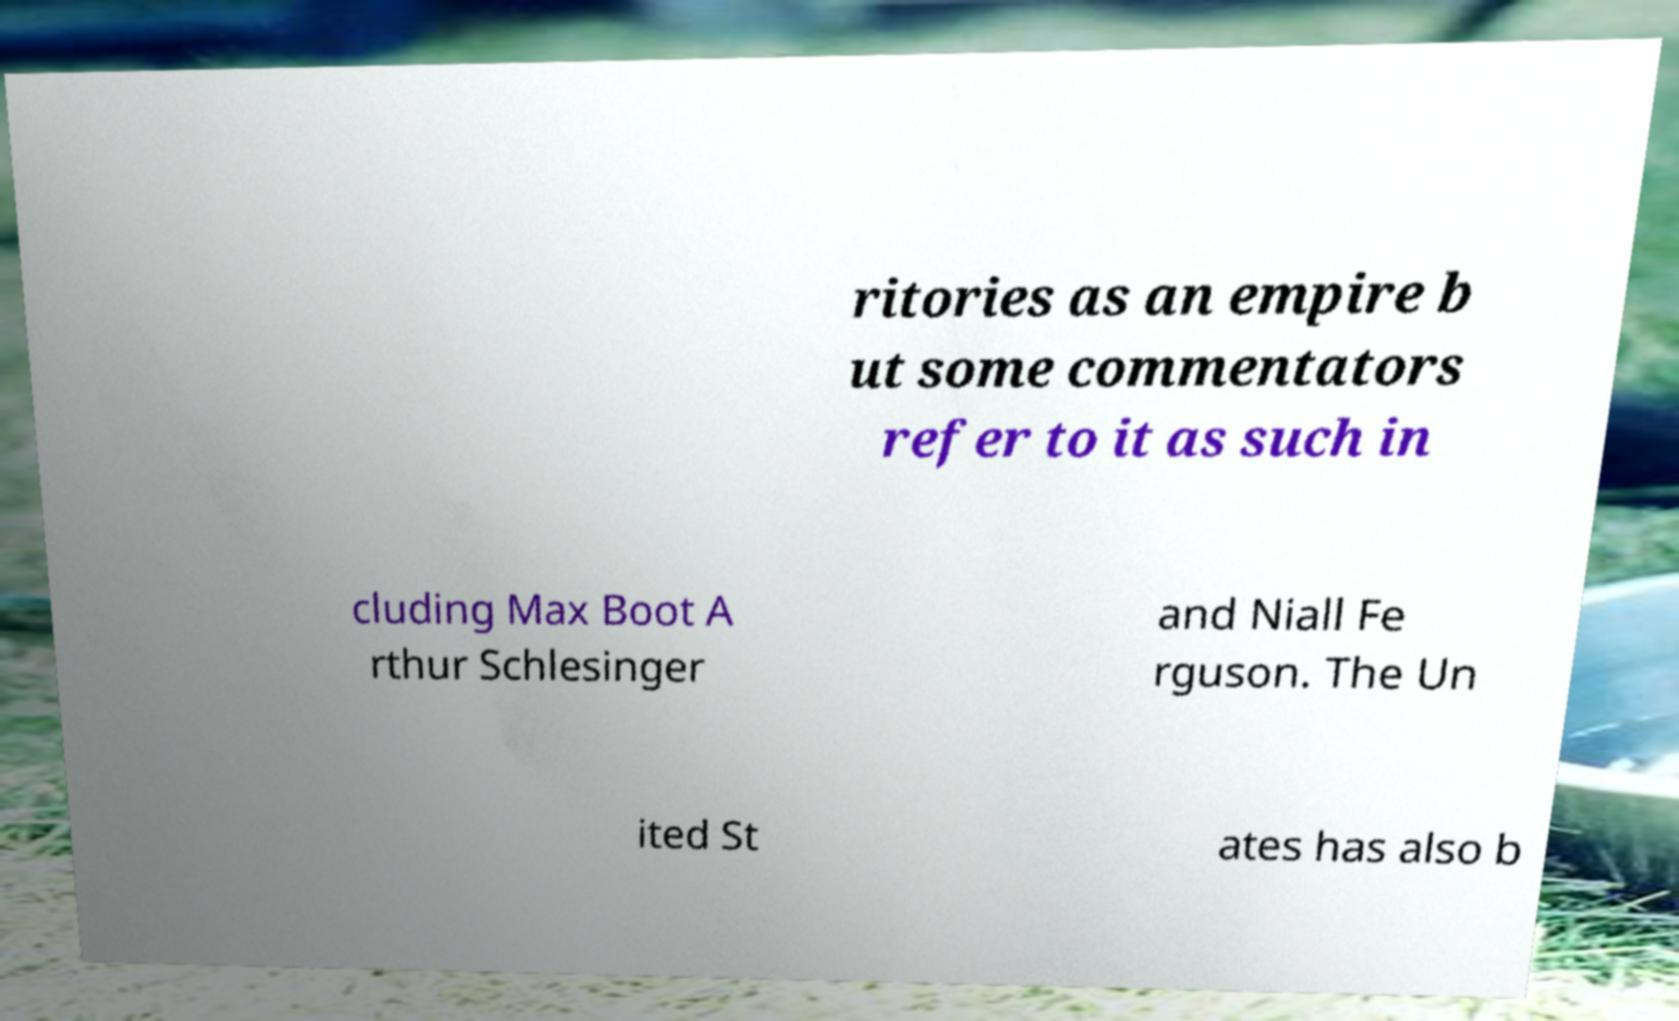What messages or text are displayed in this image? I need them in a readable, typed format. ritories as an empire b ut some commentators refer to it as such in cluding Max Boot A rthur Schlesinger and Niall Fe rguson. The Un ited St ates has also b 